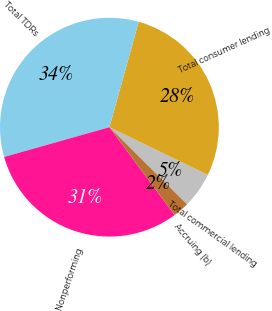<chart> <loc_0><loc_0><loc_500><loc_500><pie_chart><fcel>Total commercial lending<fcel>Total consumer lending<fcel>Total TDRs<fcel>Nonperforming<fcel>Accruing (b)<nl><fcel>5.29%<fcel>27.85%<fcel>33.7%<fcel>30.78%<fcel>2.37%<nl></chart> 